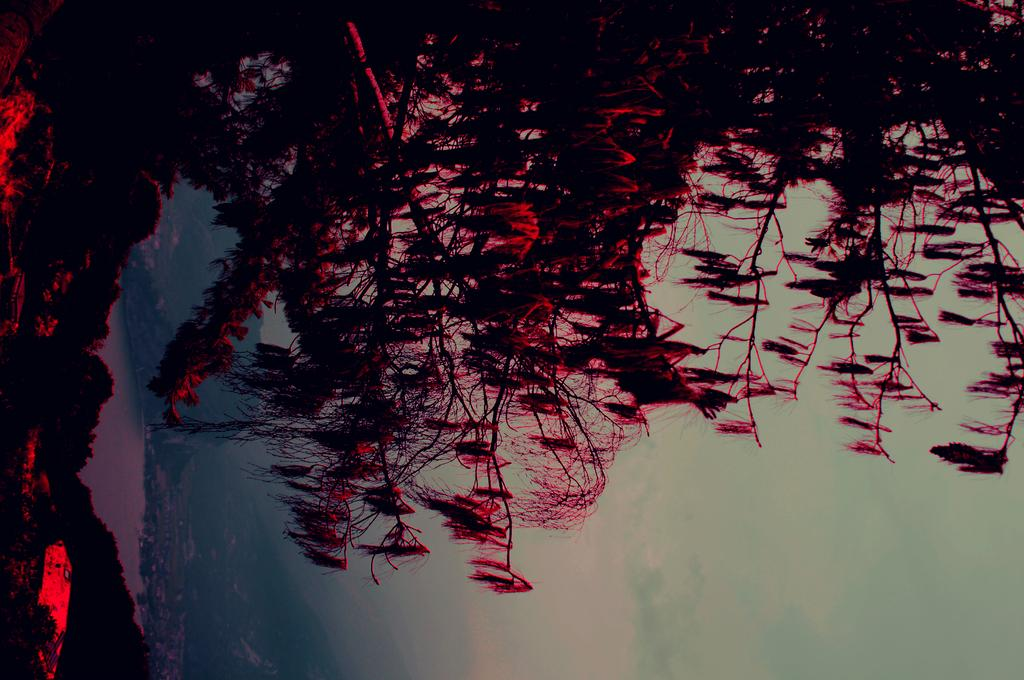What type of vegetation can be seen in the image? There are trees in the image. What natural element is visible in the image? There is water visible in the image. What can be seen in the sky in the image? There are clouds in the image. What type of stick can be seen being used to process breakfast in the image? There is no stick or breakfast present in the image; it features trees, water, and clouds. 